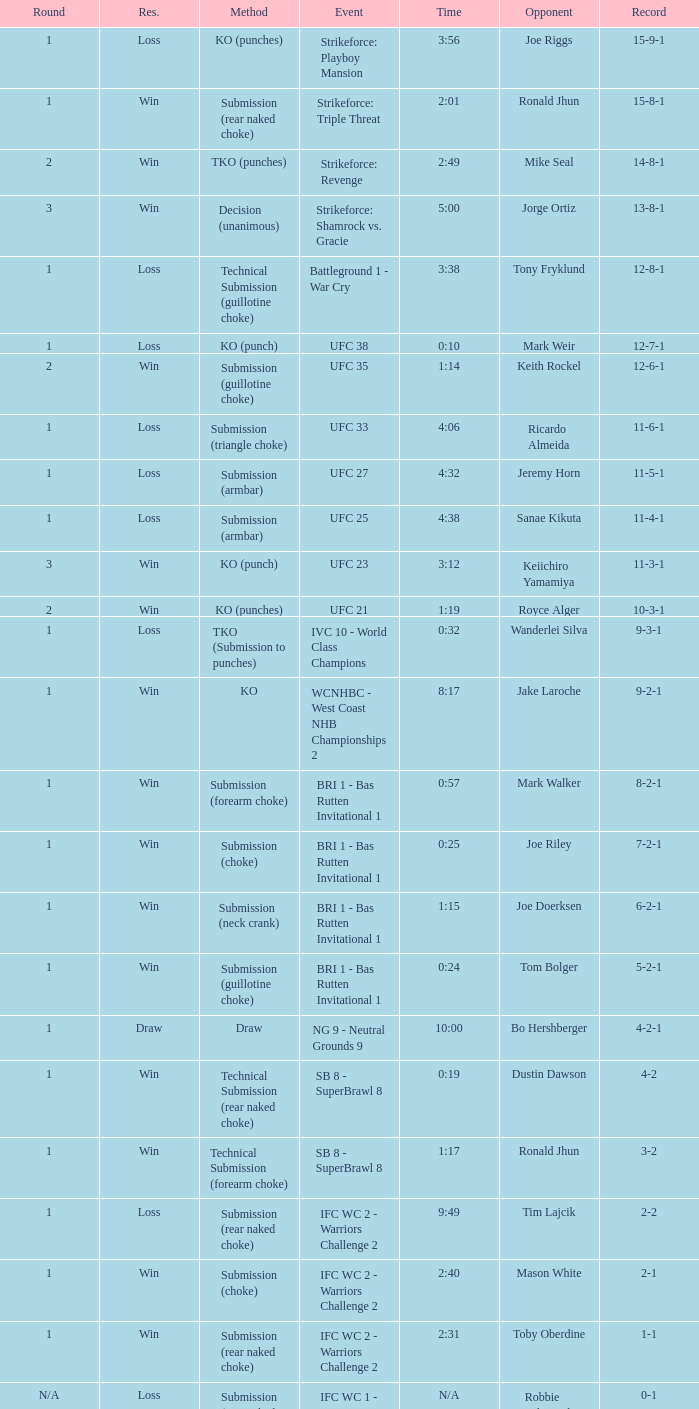What is the record during the event, UFC 27? 11-5-1. 